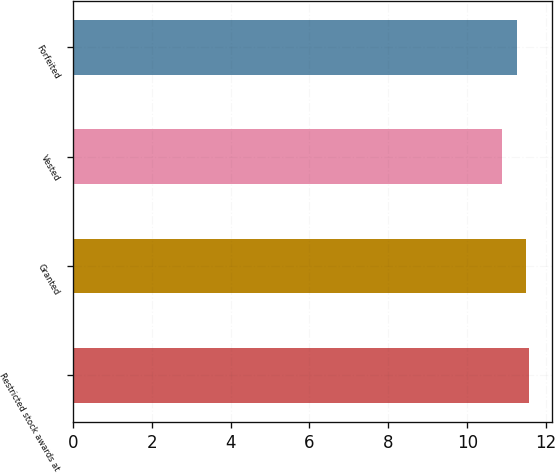Convert chart to OTSL. <chart><loc_0><loc_0><loc_500><loc_500><bar_chart><fcel>Restricted stock awards at<fcel>Granted<fcel>Vested<fcel>Forfeited<nl><fcel>11.56<fcel>11.49<fcel>10.87<fcel>11.27<nl></chart> 